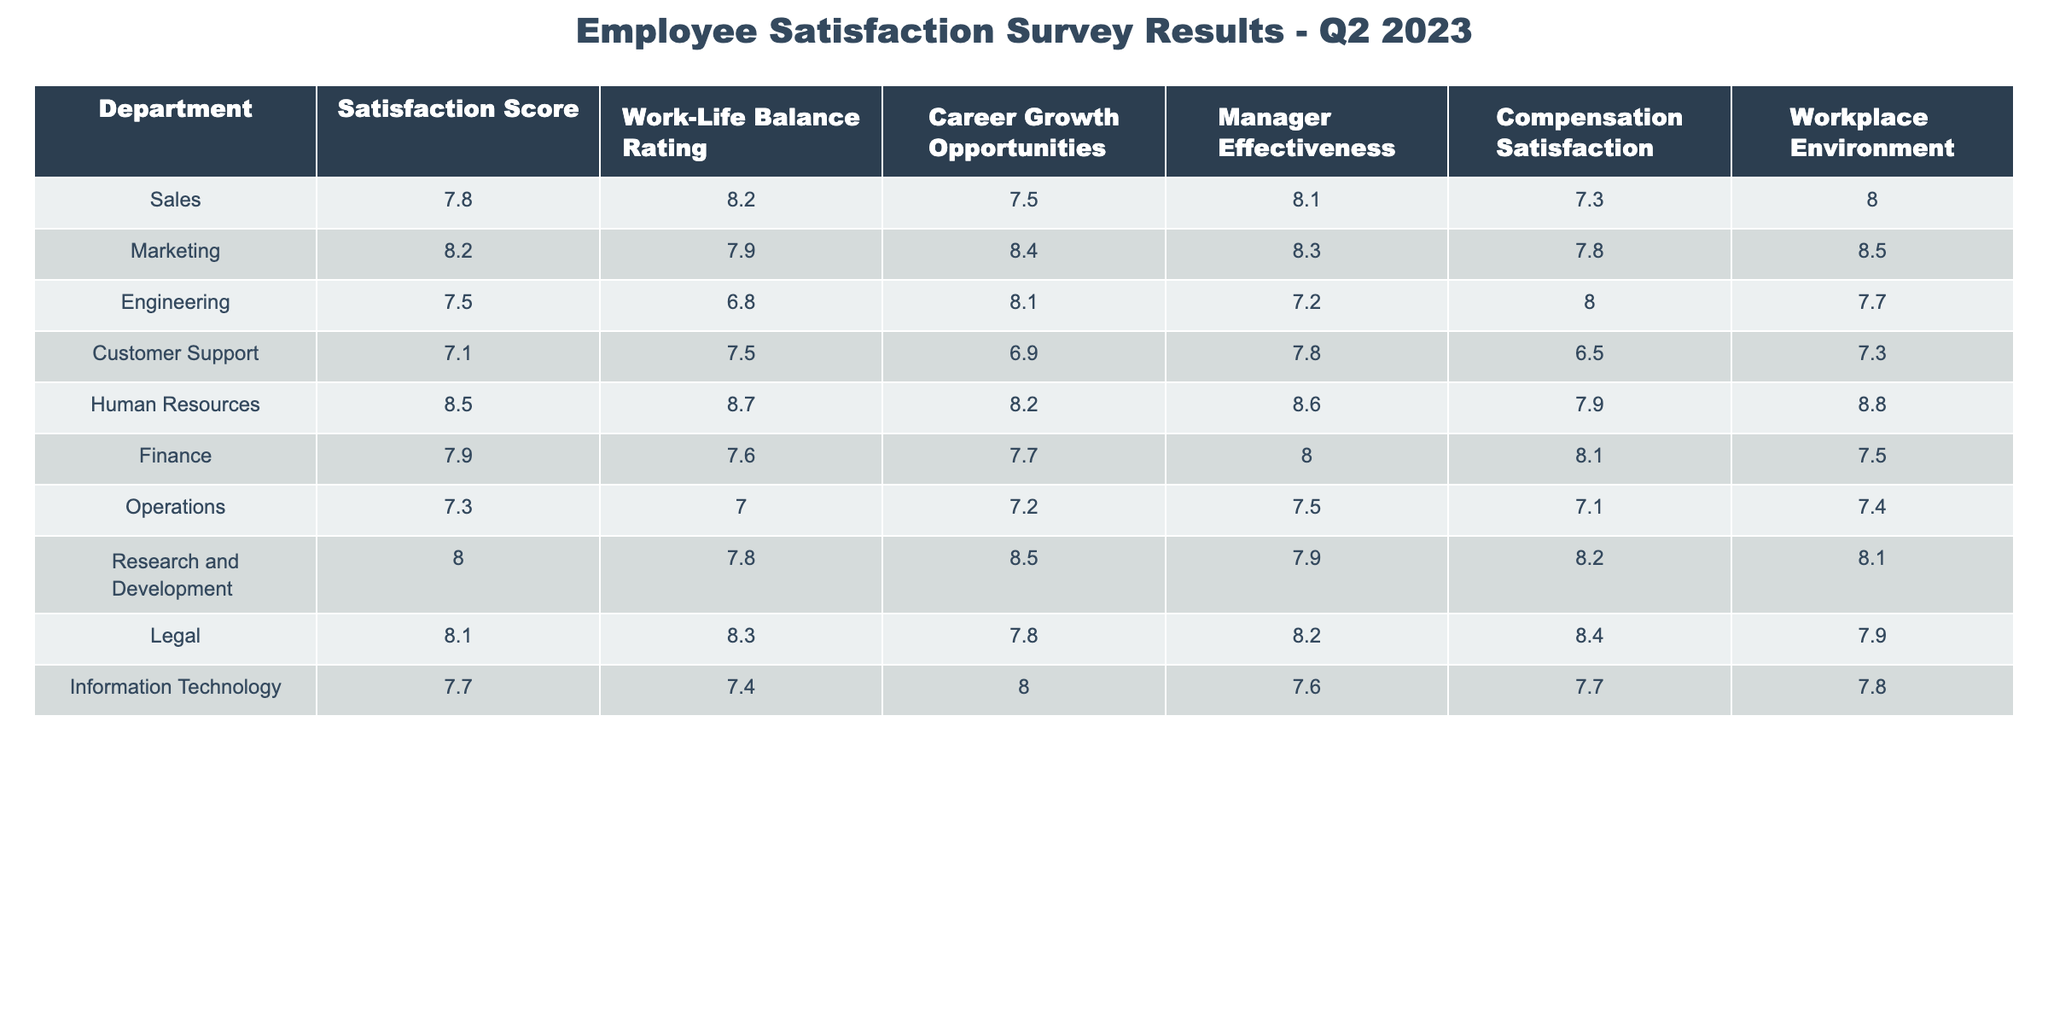What is the Satisfaction Score for the Marketing department? The Satisfaction Score for the Marketing department is listed directly in the table under the Satisfaction Score column. It shows a score of 8.2.
Answer: 8.2 Which department has the lowest Work-Life Balance Rating? By looking at the Work-Life Balance Rating column, the lowest rating is 6.8, which is for the Engineering department.
Answer: Engineering What is the average Manager Effectiveness score across all departments? To find the average, sum the Manager Effectiveness scores: (8.1 + 8.3 + 7.2 + 7.8 + 8.6 + 8.0 + 7.5 + 7.9 + 8.2 + 7.6) = 79.2. Since there are 10 departments, the average is 79.2/10 = 7.92.
Answer: 7.92 Is the Compensation Satisfaction score for the Customer Support department greater than 7? The Compensation Satisfaction score for Customer Support is 6.5, which is less than 7, making the statement false.
Answer: False Which department has both the highest Career Growth Opportunities and Workplace Environment ratings? Reviewing the Career Growth Opportunities, the highest rating is 8.5 for Research and Development, and for Workplace Environment, the highest rating is 8.8 for Human Resources. Thus, no single department has both the highest ratings.
Answer: None What is the difference between the Satisfaction Score of Human Resources and Operations? The Satisfaction Score for Human Resources is 8.5 and for Operations, it is 7.3. The difference is calculated as 8.5 - 7.3 = 1.2.
Answer: 1.2 Does any department have a score of 8.0 or higher in both Compensation Satisfaction and Work-Life Balance Rating? Looking at the respective columns, Human Resources has 7.9 in Compensation Satisfaction and 8.7 in Work-Life Balance Rating, while Legal has 8.4 in Compensation and 8.3 in Work-Life. Both have not achieved the criteria of 8.0 in both, making it a false statement.
Answer: False What is the total Satisfaction Score of the Sales and Engineering departments combined? The Satisfaction Score for Sales is 7.8 and for Engineering is 7.5. By adding these two scores together, we get 7.8 + 7.5 = 15.3.
Answer: 15.3 Which department has a higher Work-Life Balance Rating: Finance or Information Technology? The Work-Life Balance Rating for Finance is 7.6, while for Information Technology it is 7.4. By comparing these values, Finance has a higher Work-Life Balance Rating.
Answer: Finance What is the highest score in the Workplace Environment across all departments? The Workplace Environment column shows that Human Resources has the highest score of 8.8, thus this is the maximum score.
Answer: 8.8 Is there a direct correlation between Manager Effectiveness and Satisfaction Score for any department? By examining both scores closely, we can see that for example, Marketing has a Manager Effectiveness of 8.3 and a Satisfaction Score of 8.2. Both scores are high, hinting at some correlation but not confirming it directly without a broader statistical analysis. Therefore, it would be more complex to definitively state correlation without additional data.
Answer: Complex reasoning required 